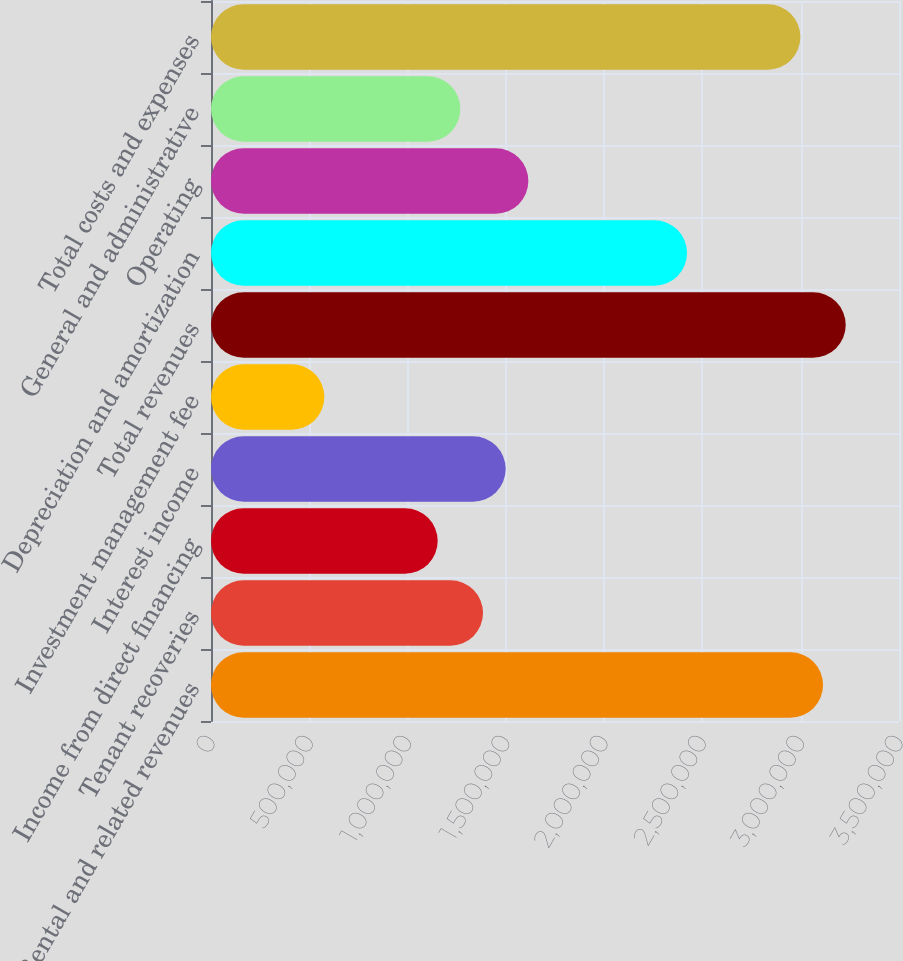<chart> <loc_0><loc_0><loc_500><loc_500><bar_chart><fcel>Rental and related revenues<fcel>Tenant recoveries<fcel>Income from direct financing<fcel>Interest income<fcel>Investment management fee<fcel>Total revenues<fcel>Depreciation and amortization<fcel>Operating<fcel>General and administrative<fcel>Total costs and expenses<nl><fcel>3.11361e+06<fcel>1.38383e+06<fcel>1.15319e+06<fcel>1.49914e+06<fcel>576594<fcel>3.22892e+06<fcel>2.42169e+06<fcel>1.61446e+06<fcel>1.26851e+06<fcel>2.99829e+06<nl></chart> 